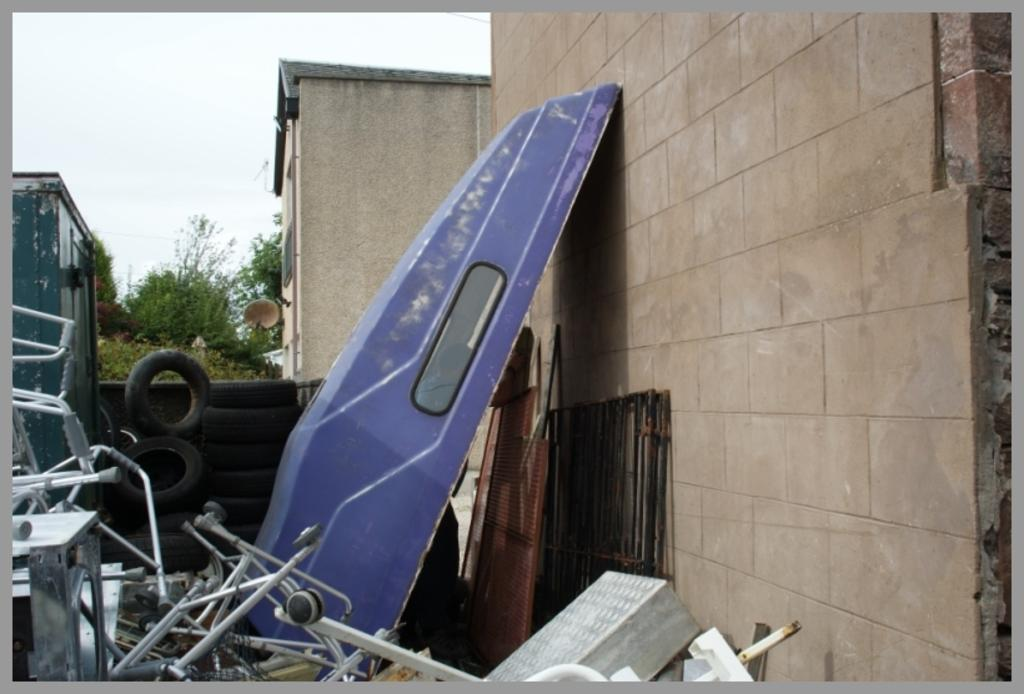What objects are present in the image? There are spare parts in the image. Where are the spare parts located? The spare parts are placed beside a wall. What type of lamp is hanging above the spare parts in the image? There is no lamp present in the image; it only features spare parts placed beside a wall. 